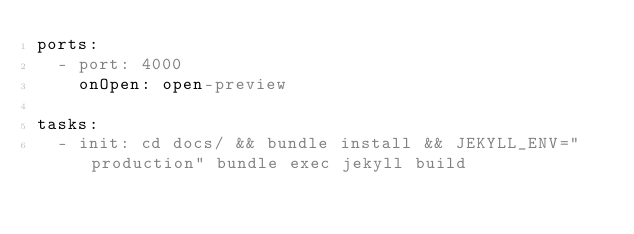<code> <loc_0><loc_0><loc_500><loc_500><_YAML_>ports:
  - port: 4000
    onOpen: open-preview

tasks:
  - init: cd docs/ && bundle install && JEKYLL_ENV="production" bundle exec jekyll build
</code> 